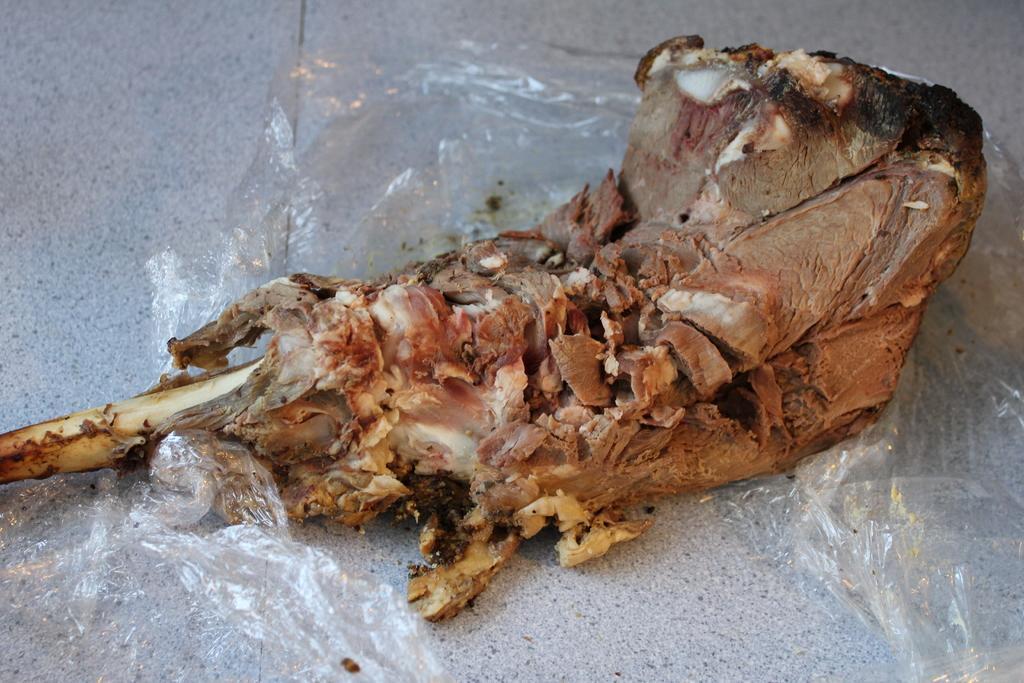Could you give a brief overview of what you see in this image? Here we can see food and a plastic cover on a platform. 